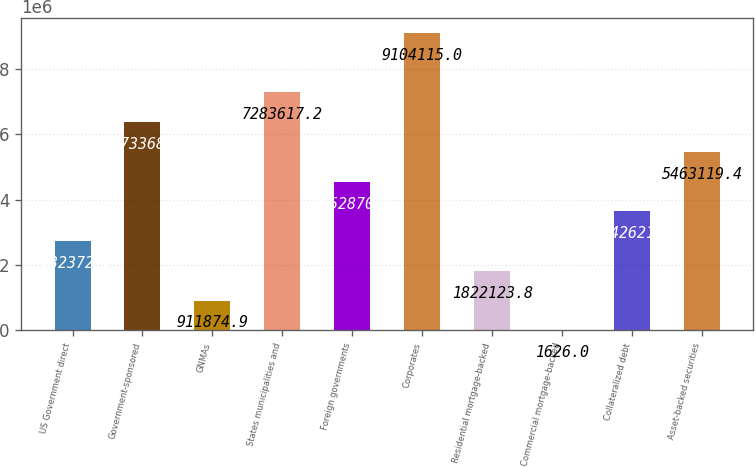<chart> <loc_0><loc_0><loc_500><loc_500><bar_chart><fcel>US Government direct<fcel>Government-sponsored<fcel>GNMAs<fcel>States municipalities and<fcel>Foreign governments<fcel>Corporates<fcel>Residential mortgage-backed<fcel>Commercial mortgage-backed<fcel>Collateralized debt<fcel>Asset-backed securities<nl><fcel>2.73237e+06<fcel>6.37337e+06<fcel>911875<fcel>7.28362e+06<fcel>4.55287e+06<fcel>9.10412e+06<fcel>1.82212e+06<fcel>1626<fcel>3.64262e+06<fcel>5.46312e+06<nl></chart> 